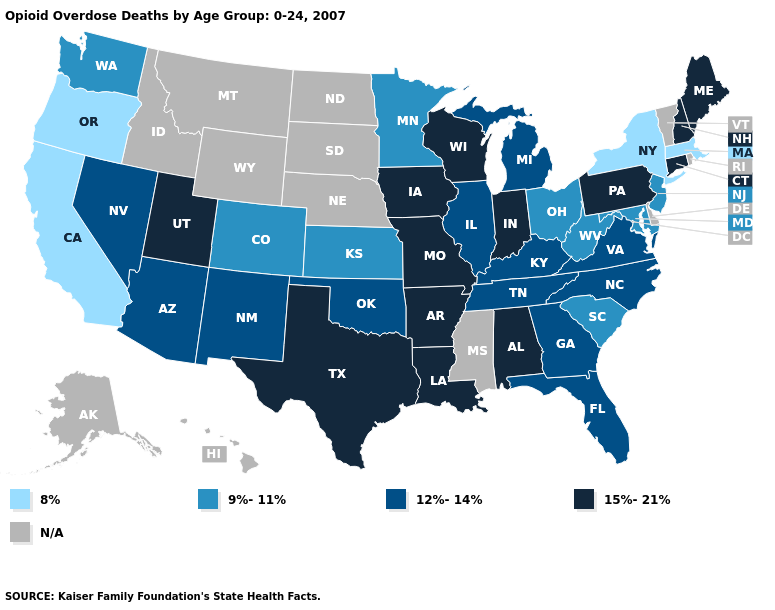What is the value of Iowa?
Quick response, please. 15%-21%. Does the map have missing data?
Answer briefly. Yes. Name the states that have a value in the range 12%-14%?
Write a very short answer. Arizona, Florida, Georgia, Illinois, Kentucky, Michigan, Nevada, New Mexico, North Carolina, Oklahoma, Tennessee, Virginia. Which states hav the highest value in the South?
Write a very short answer. Alabama, Arkansas, Louisiana, Texas. Name the states that have a value in the range N/A?
Be succinct. Alaska, Delaware, Hawaii, Idaho, Mississippi, Montana, Nebraska, North Dakota, Rhode Island, South Dakota, Vermont, Wyoming. Which states have the lowest value in the South?
Concise answer only. Maryland, South Carolina, West Virginia. Which states have the lowest value in the USA?
Answer briefly. California, Massachusetts, New York, Oregon. Name the states that have a value in the range 8%?
Answer briefly. California, Massachusetts, New York, Oregon. What is the highest value in states that border California?
Keep it brief. 12%-14%. Name the states that have a value in the range 12%-14%?
Answer briefly. Arizona, Florida, Georgia, Illinois, Kentucky, Michigan, Nevada, New Mexico, North Carolina, Oklahoma, Tennessee, Virginia. Does Kansas have the highest value in the USA?
Write a very short answer. No. Does the map have missing data?
Give a very brief answer. Yes. What is the lowest value in states that border Indiana?
Give a very brief answer. 9%-11%. Which states have the lowest value in the USA?
Keep it brief. California, Massachusetts, New York, Oregon. What is the value of Connecticut?
Keep it brief. 15%-21%. 